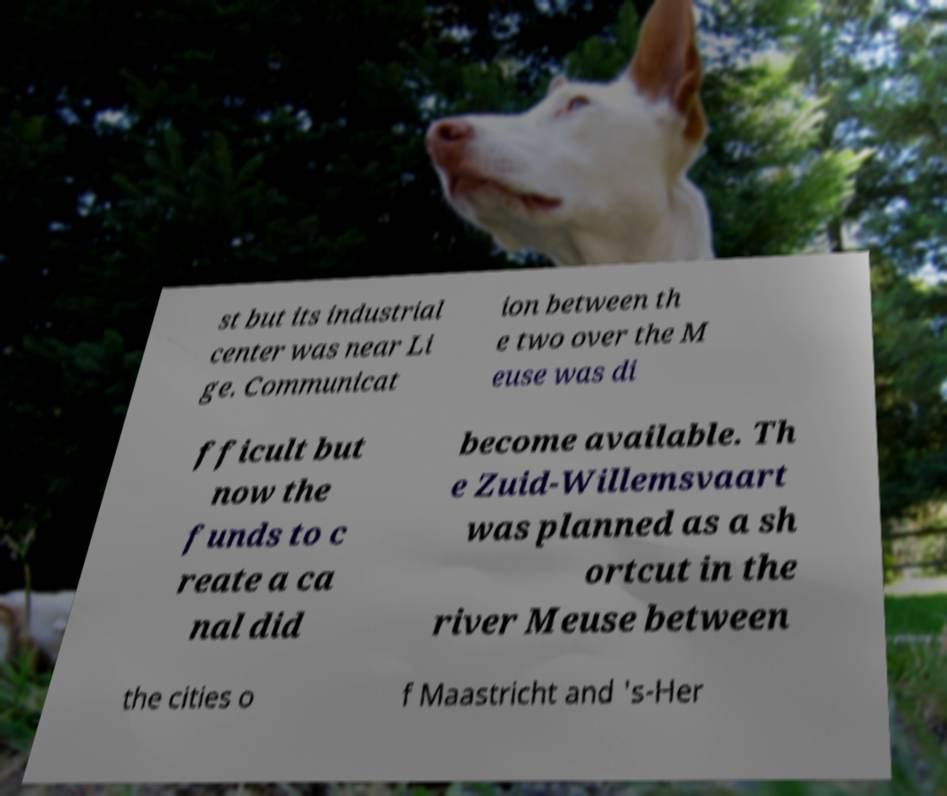Can you read and provide the text displayed in the image?This photo seems to have some interesting text. Can you extract and type it out for me? st but its industrial center was near Li ge. Communicat ion between th e two over the M euse was di fficult but now the funds to c reate a ca nal did become available. Th e Zuid-Willemsvaart was planned as a sh ortcut in the river Meuse between the cities o f Maastricht and 's-Her 